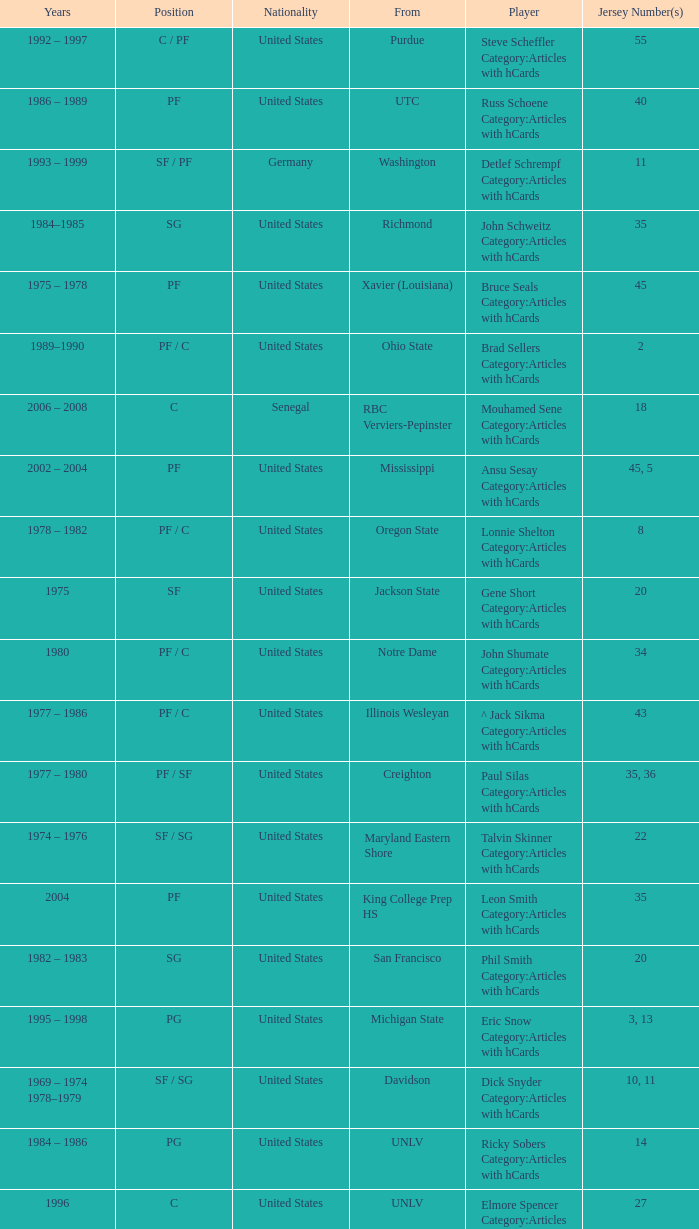Who wears the jersey number 20 and has the position of SG? Phil Smith Category:Articles with hCards, Jon Sundvold Category:Articles with hCards. 